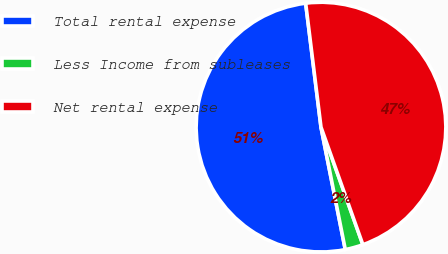Convert chart to OTSL. <chart><loc_0><loc_0><loc_500><loc_500><pie_chart><fcel>Total rental expense<fcel>Less Income from subleases<fcel>Net rental expense<nl><fcel>51.16%<fcel>2.33%<fcel>46.51%<nl></chart> 